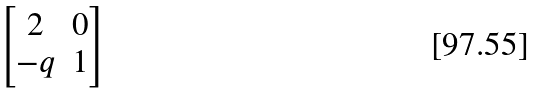Convert formula to latex. <formula><loc_0><loc_0><loc_500><loc_500>\begin{bmatrix} 2 & 0 \\ - q & 1 \end{bmatrix}</formula> 